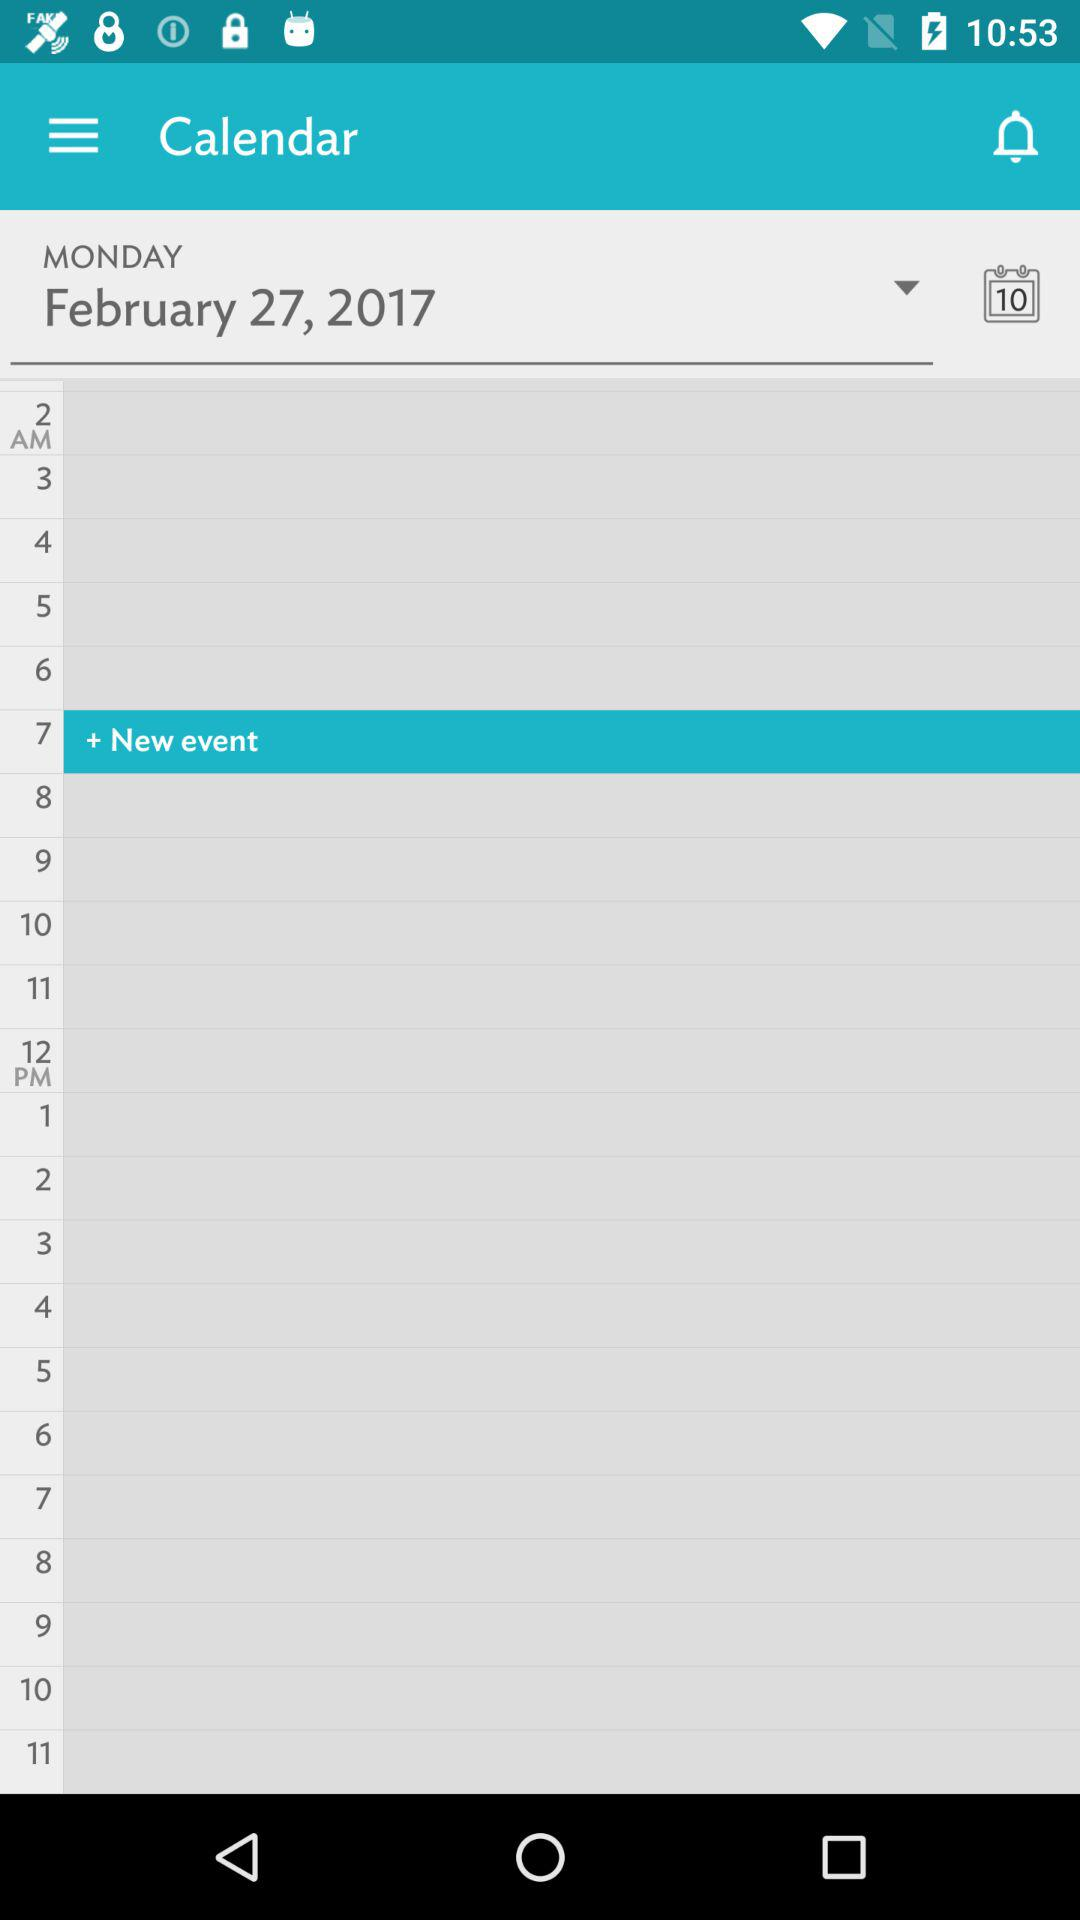For which date can the new event be set? The new event can be set for Monday, February 27, 2017. 